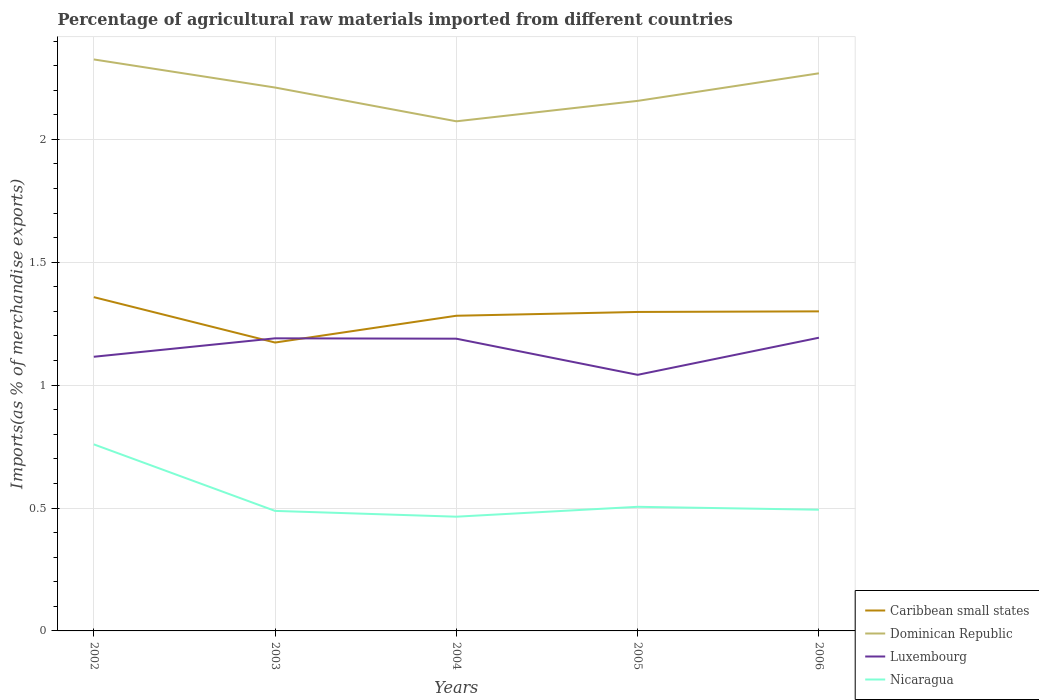Is the number of lines equal to the number of legend labels?
Ensure brevity in your answer.  Yes. Across all years, what is the maximum percentage of imports to different countries in Dominican Republic?
Keep it short and to the point. 2.07. In which year was the percentage of imports to different countries in Dominican Republic maximum?
Your answer should be compact. 2004. What is the total percentage of imports to different countries in Nicaragua in the graph?
Your answer should be compact. -0.03. What is the difference between the highest and the second highest percentage of imports to different countries in Dominican Republic?
Make the answer very short. 0.25. What is the difference between the highest and the lowest percentage of imports to different countries in Nicaragua?
Ensure brevity in your answer.  1. What is the difference between two consecutive major ticks on the Y-axis?
Offer a terse response. 0.5. Are the values on the major ticks of Y-axis written in scientific E-notation?
Provide a succinct answer. No. Does the graph contain grids?
Give a very brief answer. Yes. Where does the legend appear in the graph?
Your answer should be very brief. Bottom right. What is the title of the graph?
Offer a very short reply. Percentage of agricultural raw materials imported from different countries. Does "Faeroe Islands" appear as one of the legend labels in the graph?
Give a very brief answer. No. What is the label or title of the Y-axis?
Offer a very short reply. Imports(as % of merchandise exports). What is the Imports(as % of merchandise exports) of Caribbean small states in 2002?
Offer a very short reply. 1.36. What is the Imports(as % of merchandise exports) in Dominican Republic in 2002?
Make the answer very short. 2.33. What is the Imports(as % of merchandise exports) in Luxembourg in 2002?
Make the answer very short. 1.12. What is the Imports(as % of merchandise exports) of Nicaragua in 2002?
Make the answer very short. 0.76. What is the Imports(as % of merchandise exports) of Caribbean small states in 2003?
Make the answer very short. 1.17. What is the Imports(as % of merchandise exports) of Dominican Republic in 2003?
Keep it short and to the point. 2.21. What is the Imports(as % of merchandise exports) in Luxembourg in 2003?
Your answer should be compact. 1.19. What is the Imports(as % of merchandise exports) of Nicaragua in 2003?
Offer a very short reply. 0.49. What is the Imports(as % of merchandise exports) in Caribbean small states in 2004?
Your response must be concise. 1.28. What is the Imports(as % of merchandise exports) of Dominican Republic in 2004?
Keep it short and to the point. 2.07. What is the Imports(as % of merchandise exports) of Luxembourg in 2004?
Offer a very short reply. 1.19. What is the Imports(as % of merchandise exports) of Nicaragua in 2004?
Your answer should be compact. 0.46. What is the Imports(as % of merchandise exports) of Caribbean small states in 2005?
Provide a short and direct response. 1.3. What is the Imports(as % of merchandise exports) of Dominican Republic in 2005?
Provide a short and direct response. 2.16. What is the Imports(as % of merchandise exports) of Luxembourg in 2005?
Your answer should be compact. 1.04. What is the Imports(as % of merchandise exports) in Nicaragua in 2005?
Make the answer very short. 0.5. What is the Imports(as % of merchandise exports) in Caribbean small states in 2006?
Keep it short and to the point. 1.3. What is the Imports(as % of merchandise exports) in Dominican Republic in 2006?
Provide a succinct answer. 2.27. What is the Imports(as % of merchandise exports) in Luxembourg in 2006?
Your response must be concise. 1.19. What is the Imports(as % of merchandise exports) in Nicaragua in 2006?
Your answer should be very brief. 0.49. Across all years, what is the maximum Imports(as % of merchandise exports) in Caribbean small states?
Provide a succinct answer. 1.36. Across all years, what is the maximum Imports(as % of merchandise exports) of Dominican Republic?
Your answer should be very brief. 2.33. Across all years, what is the maximum Imports(as % of merchandise exports) of Luxembourg?
Keep it short and to the point. 1.19. Across all years, what is the maximum Imports(as % of merchandise exports) in Nicaragua?
Your answer should be compact. 0.76. Across all years, what is the minimum Imports(as % of merchandise exports) in Caribbean small states?
Make the answer very short. 1.17. Across all years, what is the minimum Imports(as % of merchandise exports) in Dominican Republic?
Make the answer very short. 2.07. Across all years, what is the minimum Imports(as % of merchandise exports) of Luxembourg?
Your response must be concise. 1.04. Across all years, what is the minimum Imports(as % of merchandise exports) in Nicaragua?
Provide a short and direct response. 0.46. What is the total Imports(as % of merchandise exports) in Caribbean small states in the graph?
Make the answer very short. 6.41. What is the total Imports(as % of merchandise exports) of Dominican Republic in the graph?
Provide a short and direct response. 11.03. What is the total Imports(as % of merchandise exports) in Luxembourg in the graph?
Ensure brevity in your answer.  5.73. What is the total Imports(as % of merchandise exports) in Nicaragua in the graph?
Give a very brief answer. 2.71. What is the difference between the Imports(as % of merchandise exports) in Caribbean small states in 2002 and that in 2003?
Ensure brevity in your answer.  0.18. What is the difference between the Imports(as % of merchandise exports) in Dominican Republic in 2002 and that in 2003?
Your answer should be very brief. 0.11. What is the difference between the Imports(as % of merchandise exports) in Luxembourg in 2002 and that in 2003?
Provide a short and direct response. -0.07. What is the difference between the Imports(as % of merchandise exports) of Nicaragua in 2002 and that in 2003?
Provide a short and direct response. 0.27. What is the difference between the Imports(as % of merchandise exports) in Caribbean small states in 2002 and that in 2004?
Your answer should be very brief. 0.08. What is the difference between the Imports(as % of merchandise exports) of Dominican Republic in 2002 and that in 2004?
Provide a short and direct response. 0.25. What is the difference between the Imports(as % of merchandise exports) in Luxembourg in 2002 and that in 2004?
Provide a succinct answer. -0.07. What is the difference between the Imports(as % of merchandise exports) in Nicaragua in 2002 and that in 2004?
Provide a short and direct response. 0.29. What is the difference between the Imports(as % of merchandise exports) of Caribbean small states in 2002 and that in 2005?
Offer a terse response. 0.06. What is the difference between the Imports(as % of merchandise exports) of Dominican Republic in 2002 and that in 2005?
Make the answer very short. 0.17. What is the difference between the Imports(as % of merchandise exports) of Luxembourg in 2002 and that in 2005?
Provide a succinct answer. 0.07. What is the difference between the Imports(as % of merchandise exports) of Nicaragua in 2002 and that in 2005?
Your answer should be compact. 0.25. What is the difference between the Imports(as % of merchandise exports) of Caribbean small states in 2002 and that in 2006?
Your answer should be compact. 0.06. What is the difference between the Imports(as % of merchandise exports) of Dominican Republic in 2002 and that in 2006?
Provide a succinct answer. 0.06. What is the difference between the Imports(as % of merchandise exports) of Luxembourg in 2002 and that in 2006?
Your answer should be compact. -0.08. What is the difference between the Imports(as % of merchandise exports) of Nicaragua in 2002 and that in 2006?
Provide a short and direct response. 0.27. What is the difference between the Imports(as % of merchandise exports) of Caribbean small states in 2003 and that in 2004?
Provide a short and direct response. -0.11. What is the difference between the Imports(as % of merchandise exports) in Dominican Republic in 2003 and that in 2004?
Provide a succinct answer. 0.14. What is the difference between the Imports(as % of merchandise exports) in Luxembourg in 2003 and that in 2004?
Provide a short and direct response. 0. What is the difference between the Imports(as % of merchandise exports) of Nicaragua in 2003 and that in 2004?
Offer a terse response. 0.02. What is the difference between the Imports(as % of merchandise exports) in Caribbean small states in 2003 and that in 2005?
Ensure brevity in your answer.  -0.12. What is the difference between the Imports(as % of merchandise exports) in Dominican Republic in 2003 and that in 2005?
Keep it short and to the point. 0.05. What is the difference between the Imports(as % of merchandise exports) in Luxembourg in 2003 and that in 2005?
Your answer should be compact. 0.15. What is the difference between the Imports(as % of merchandise exports) in Nicaragua in 2003 and that in 2005?
Offer a terse response. -0.02. What is the difference between the Imports(as % of merchandise exports) of Caribbean small states in 2003 and that in 2006?
Ensure brevity in your answer.  -0.13. What is the difference between the Imports(as % of merchandise exports) of Dominican Republic in 2003 and that in 2006?
Your response must be concise. -0.06. What is the difference between the Imports(as % of merchandise exports) of Luxembourg in 2003 and that in 2006?
Your response must be concise. -0. What is the difference between the Imports(as % of merchandise exports) of Nicaragua in 2003 and that in 2006?
Offer a terse response. -0. What is the difference between the Imports(as % of merchandise exports) of Caribbean small states in 2004 and that in 2005?
Your answer should be very brief. -0.02. What is the difference between the Imports(as % of merchandise exports) in Dominican Republic in 2004 and that in 2005?
Keep it short and to the point. -0.08. What is the difference between the Imports(as % of merchandise exports) of Luxembourg in 2004 and that in 2005?
Ensure brevity in your answer.  0.15. What is the difference between the Imports(as % of merchandise exports) of Nicaragua in 2004 and that in 2005?
Provide a succinct answer. -0.04. What is the difference between the Imports(as % of merchandise exports) of Caribbean small states in 2004 and that in 2006?
Provide a succinct answer. -0.02. What is the difference between the Imports(as % of merchandise exports) of Dominican Republic in 2004 and that in 2006?
Give a very brief answer. -0.2. What is the difference between the Imports(as % of merchandise exports) in Luxembourg in 2004 and that in 2006?
Your response must be concise. -0. What is the difference between the Imports(as % of merchandise exports) in Nicaragua in 2004 and that in 2006?
Make the answer very short. -0.03. What is the difference between the Imports(as % of merchandise exports) in Caribbean small states in 2005 and that in 2006?
Ensure brevity in your answer.  -0. What is the difference between the Imports(as % of merchandise exports) of Dominican Republic in 2005 and that in 2006?
Give a very brief answer. -0.11. What is the difference between the Imports(as % of merchandise exports) of Luxembourg in 2005 and that in 2006?
Make the answer very short. -0.15. What is the difference between the Imports(as % of merchandise exports) of Nicaragua in 2005 and that in 2006?
Give a very brief answer. 0.01. What is the difference between the Imports(as % of merchandise exports) in Caribbean small states in 2002 and the Imports(as % of merchandise exports) in Dominican Republic in 2003?
Offer a terse response. -0.85. What is the difference between the Imports(as % of merchandise exports) of Caribbean small states in 2002 and the Imports(as % of merchandise exports) of Luxembourg in 2003?
Your answer should be very brief. 0.17. What is the difference between the Imports(as % of merchandise exports) in Caribbean small states in 2002 and the Imports(as % of merchandise exports) in Nicaragua in 2003?
Your response must be concise. 0.87. What is the difference between the Imports(as % of merchandise exports) in Dominican Republic in 2002 and the Imports(as % of merchandise exports) in Luxembourg in 2003?
Provide a succinct answer. 1.13. What is the difference between the Imports(as % of merchandise exports) of Dominican Republic in 2002 and the Imports(as % of merchandise exports) of Nicaragua in 2003?
Your answer should be very brief. 1.84. What is the difference between the Imports(as % of merchandise exports) in Luxembourg in 2002 and the Imports(as % of merchandise exports) in Nicaragua in 2003?
Provide a short and direct response. 0.63. What is the difference between the Imports(as % of merchandise exports) in Caribbean small states in 2002 and the Imports(as % of merchandise exports) in Dominican Republic in 2004?
Your response must be concise. -0.72. What is the difference between the Imports(as % of merchandise exports) of Caribbean small states in 2002 and the Imports(as % of merchandise exports) of Luxembourg in 2004?
Offer a terse response. 0.17. What is the difference between the Imports(as % of merchandise exports) in Caribbean small states in 2002 and the Imports(as % of merchandise exports) in Nicaragua in 2004?
Offer a terse response. 0.89. What is the difference between the Imports(as % of merchandise exports) of Dominican Republic in 2002 and the Imports(as % of merchandise exports) of Luxembourg in 2004?
Your response must be concise. 1.14. What is the difference between the Imports(as % of merchandise exports) of Dominican Republic in 2002 and the Imports(as % of merchandise exports) of Nicaragua in 2004?
Your answer should be compact. 1.86. What is the difference between the Imports(as % of merchandise exports) in Luxembourg in 2002 and the Imports(as % of merchandise exports) in Nicaragua in 2004?
Offer a very short reply. 0.65. What is the difference between the Imports(as % of merchandise exports) of Caribbean small states in 2002 and the Imports(as % of merchandise exports) of Dominican Republic in 2005?
Make the answer very short. -0.8. What is the difference between the Imports(as % of merchandise exports) of Caribbean small states in 2002 and the Imports(as % of merchandise exports) of Luxembourg in 2005?
Give a very brief answer. 0.32. What is the difference between the Imports(as % of merchandise exports) of Caribbean small states in 2002 and the Imports(as % of merchandise exports) of Nicaragua in 2005?
Ensure brevity in your answer.  0.85. What is the difference between the Imports(as % of merchandise exports) of Dominican Republic in 2002 and the Imports(as % of merchandise exports) of Luxembourg in 2005?
Offer a terse response. 1.28. What is the difference between the Imports(as % of merchandise exports) in Dominican Republic in 2002 and the Imports(as % of merchandise exports) in Nicaragua in 2005?
Provide a succinct answer. 1.82. What is the difference between the Imports(as % of merchandise exports) in Luxembourg in 2002 and the Imports(as % of merchandise exports) in Nicaragua in 2005?
Keep it short and to the point. 0.61. What is the difference between the Imports(as % of merchandise exports) in Caribbean small states in 2002 and the Imports(as % of merchandise exports) in Dominican Republic in 2006?
Keep it short and to the point. -0.91. What is the difference between the Imports(as % of merchandise exports) of Caribbean small states in 2002 and the Imports(as % of merchandise exports) of Luxembourg in 2006?
Offer a terse response. 0.17. What is the difference between the Imports(as % of merchandise exports) of Caribbean small states in 2002 and the Imports(as % of merchandise exports) of Nicaragua in 2006?
Offer a terse response. 0.86. What is the difference between the Imports(as % of merchandise exports) in Dominican Republic in 2002 and the Imports(as % of merchandise exports) in Luxembourg in 2006?
Provide a short and direct response. 1.13. What is the difference between the Imports(as % of merchandise exports) in Dominican Republic in 2002 and the Imports(as % of merchandise exports) in Nicaragua in 2006?
Provide a short and direct response. 1.83. What is the difference between the Imports(as % of merchandise exports) of Luxembourg in 2002 and the Imports(as % of merchandise exports) of Nicaragua in 2006?
Keep it short and to the point. 0.62. What is the difference between the Imports(as % of merchandise exports) of Caribbean small states in 2003 and the Imports(as % of merchandise exports) of Dominican Republic in 2004?
Provide a succinct answer. -0.9. What is the difference between the Imports(as % of merchandise exports) in Caribbean small states in 2003 and the Imports(as % of merchandise exports) in Luxembourg in 2004?
Your answer should be very brief. -0.02. What is the difference between the Imports(as % of merchandise exports) of Caribbean small states in 2003 and the Imports(as % of merchandise exports) of Nicaragua in 2004?
Your answer should be compact. 0.71. What is the difference between the Imports(as % of merchandise exports) of Dominican Republic in 2003 and the Imports(as % of merchandise exports) of Luxembourg in 2004?
Provide a succinct answer. 1.02. What is the difference between the Imports(as % of merchandise exports) of Dominican Republic in 2003 and the Imports(as % of merchandise exports) of Nicaragua in 2004?
Ensure brevity in your answer.  1.75. What is the difference between the Imports(as % of merchandise exports) of Luxembourg in 2003 and the Imports(as % of merchandise exports) of Nicaragua in 2004?
Offer a terse response. 0.73. What is the difference between the Imports(as % of merchandise exports) in Caribbean small states in 2003 and the Imports(as % of merchandise exports) in Dominican Republic in 2005?
Keep it short and to the point. -0.98. What is the difference between the Imports(as % of merchandise exports) of Caribbean small states in 2003 and the Imports(as % of merchandise exports) of Luxembourg in 2005?
Your response must be concise. 0.13. What is the difference between the Imports(as % of merchandise exports) of Caribbean small states in 2003 and the Imports(as % of merchandise exports) of Nicaragua in 2005?
Provide a short and direct response. 0.67. What is the difference between the Imports(as % of merchandise exports) in Dominican Republic in 2003 and the Imports(as % of merchandise exports) in Luxembourg in 2005?
Your answer should be very brief. 1.17. What is the difference between the Imports(as % of merchandise exports) in Dominican Republic in 2003 and the Imports(as % of merchandise exports) in Nicaragua in 2005?
Ensure brevity in your answer.  1.71. What is the difference between the Imports(as % of merchandise exports) in Luxembourg in 2003 and the Imports(as % of merchandise exports) in Nicaragua in 2005?
Make the answer very short. 0.69. What is the difference between the Imports(as % of merchandise exports) in Caribbean small states in 2003 and the Imports(as % of merchandise exports) in Dominican Republic in 2006?
Provide a short and direct response. -1.1. What is the difference between the Imports(as % of merchandise exports) in Caribbean small states in 2003 and the Imports(as % of merchandise exports) in Luxembourg in 2006?
Provide a succinct answer. -0.02. What is the difference between the Imports(as % of merchandise exports) of Caribbean small states in 2003 and the Imports(as % of merchandise exports) of Nicaragua in 2006?
Provide a succinct answer. 0.68. What is the difference between the Imports(as % of merchandise exports) in Dominican Republic in 2003 and the Imports(as % of merchandise exports) in Luxembourg in 2006?
Make the answer very short. 1.02. What is the difference between the Imports(as % of merchandise exports) in Dominican Republic in 2003 and the Imports(as % of merchandise exports) in Nicaragua in 2006?
Give a very brief answer. 1.72. What is the difference between the Imports(as % of merchandise exports) of Luxembourg in 2003 and the Imports(as % of merchandise exports) of Nicaragua in 2006?
Offer a very short reply. 0.7. What is the difference between the Imports(as % of merchandise exports) in Caribbean small states in 2004 and the Imports(as % of merchandise exports) in Dominican Republic in 2005?
Make the answer very short. -0.87. What is the difference between the Imports(as % of merchandise exports) of Caribbean small states in 2004 and the Imports(as % of merchandise exports) of Luxembourg in 2005?
Your answer should be compact. 0.24. What is the difference between the Imports(as % of merchandise exports) of Caribbean small states in 2004 and the Imports(as % of merchandise exports) of Nicaragua in 2005?
Offer a very short reply. 0.78. What is the difference between the Imports(as % of merchandise exports) of Dominican Republic in 2004 and the Imports(as % of merchandise exports) of Luxembourg in 2005?
Ensure brevity in your answer.  1.03. What is the difference between the Imports(as % of merchandise exports) of Dominican Republic in 2004 and the Imports(as % of merchandise exports) of Nicaragua in 2005?
Offer a terse response. 1.57. What is the difference between the Imports(as % of merchandise exports) of Luxembourg in 2004 and the Imports(as % of merchandise exports) of Nicaragua in 2005?
Make the answer very short. 0.68. What is the difference between the Imports(as % of merchandise exports) of Caribbean small states in 2004 and the Imports(as % of merchandise exports) of Dominican Republic in 2006?
Make the answer very short. -0.99. What is the difference between the Imports(as % of merchandise exports) in Caribbean small states in 2004 and the Imports(as % of merchandise exports) in Luxembourg in 2006?
Offer a very short reply. 0.09. What is the difference between the Imports(as % of merchandise exports) in Caribbean small states in 2004 and the Imports(as % of merchandise exports) in Nicaragua in 2006?
Your response must be concise. 0.79. What is the difference between the Imports(as % of merchandise exports) of Dominican Republic in 2004 and the Imports(as % of merchandise exports) of Luxembourg in 2006?
Your answer should be very brief. 0.88. What is the difference between the Imports(as % of merchandise exports) in Dominican Republic in 2004 and the Imports(as % of merchandise exports) in Nicaragua in 2006?
Your answer should be compact. 1.58. What is the difference between the Imports(as % of merchandise exports) in Luxembourg in 2004 and the Imports(as % of merchandise exports) in Nicaragua in 2006?
Offer a very short reply. 0.7. What is the difference between the Imports(as % of merchandise exports) in Caribbean small states in 2005 and the Imports(as % of merchandise exports) in Dominican Republic in 2006?
Keep it short and to the point. -0.97. What is the difference between the Imports(as % of merchandise exports) of Caribbean small states in 2005 and the Imports(as % of merchandise exports) of Luxembourg in 2006?
Ensure brevity in your answer.  0.1. What is the difference between the Imports(as % of merchandise exports) in Caribbean small states in 2005 and the Imports(as % of merchandise exports) in Nicaragua in 2006?
Offer a terse response. 0.8. What is the difference between the Imports(as % of merchandise exports) in Dominican Republic in 2005 and the Imports(as % of merchandise exports) in Luxembourg in 2006?
Offer a very short reply. 0.96. What is the difference between the Imports(as % of merchandise exports) in Dominican Republic in 2005 and the Imports(as % of merchandise exports) in Nicaragua in 2006?
Give a very brief answer. 1.66. What is the difference between the Imports(as % of merchandise exports) in Luxembourg in 2005 and the Imports(as % of merchandise exports) in Nicaragua in 2006?
Make the answer very short. 0.55. What is the average Imports(as % of merchandise exports) in Caribbean small states per year?
Make the answer very short. 1.28. What is the average Imports(as % of merchandise exports) of Dominican Republic per year?
Provide a succinct answer. 2.21. What is the average Imports(as % of merchandise exports) of Luxembourg per year?
Offer a terse response. 1.15. What is the average Imports(as % of merchandise exports) in Nicaragua per year?
Keep it short and to the point. 0.54. In the year 2002, what is the difference between the Imports(as % of merchandise exports) of Caribbean small states and Imports(as % of merchandise exports) of Dominican Republic?
Offer a very short reply. -0.97. In the year 2002, what is the difference between the Imports(as % of merchandise exports) in Caribbean small states and Imports(as % of merchandise exports) in Luxembourg?
Offer a very short reply. 0.24. In the year 2002, what is the difference between the Imports(as % of merchandise exports) of Caribbean small states and Imports(as % of merchandise exports) of Nicaragua?
Your response must be concise. 0.6. In the year 2002, what is the difference between the Imports(as % of merchandise exports) of Dominican Republic and Imports(as % of merchandise exports) of Luxembourg?
Give a very brief answer. 1.21. In the year 2002, what is the difference between the Imports(as % of merchandise exports) in Dominican Republic and Imports(as % of merchandise exports) in Nicaragua?
Your answer should be compact. 1.57. In the year 2002, what is the difference between the Imports(as % of merchandise exports) of Luxembourg and Imports(as % of merchandise exports) of Nicaragua?
Your response must be concise. 0.36. In the year 2003, what is the difference between the Imports(as % of merchandise exports) of Caribbean small states and Imports(as % of merchandise exports) of Dominican Republic?
Your answer should be compact. -1.04. In the year 2003, what is the difference between the Imports(as % of merchandise exports) of Caribbean small states and Imports(as % of merchandise exports) of Luxembourg?
Offer a very short reply. -0.02. In the year 2003, what is the difference between the Imports(as % of merchandise exports) in Caribbean small states and Imports(as % of merchandise exports) in Nicaragua?
Provide a short and direct response. 0.69. In the year 2003, what is the difference between the Imports(as % of merchandise exports) of Dominican Republic and Imports(as % of merchandise exports) of Luxembourg?
Your answer should be compact. 1.02. In the year 2003, what is the difference between the Imports(as % of merchandise exports) of Dominican Republic and Imports(as % of merchandise exports) of Nicaragua?
Provide a succinct answer. 1.72. In the year 2003, what is the difference between the Imports(as % of merchandise exports) in Luxembourg and Imports(as % of merchandise exports) in Nicaragua?
Your answer should be very brief. 0.7. In the year 2004, what is the difference between the Imports(as % of merchandise exports) in Caribbean small states and Imports(as % of merchandise exports) in Dominican Republic?
Ensure brevity in your answer.  -0.79. In the year 2004, what is the difference between the Imports(as % of merchandise exports) in Caribbean small states and Imports(as % of merchandise exports) in Luxembourg?
Provide a succinct answer. 0.09. In the year 2004, what is the difference between the Imports(as % of merchandise exports) in Caribbean small states and Imports(as % of merchandise exports) in Nicaragua?
Your answer should be compact. 0.82. In the year 2004, what is the difference between the Imports(as % of merchandise exports) in Dominican Republic and Imports(as % of merchandise exports) in Luxembourg?
Your answer should be compact. 0.88. In the year 2004, what is the difference between the Imports(as % of merchandise exports) of Dominican Republic and Imports(as % of merchandise exports) of Nicaragua?
Provide a short and direct response. 1.61. In the year 2004, what is the difference between the Imports(as % of merchandise exports) in Luxembourg and Imports(as % of merchandise exports) in Nicaragua?
Ensure brevity in your answer.  0.72. In the year 2005, what is the difference between the Imports(as % of merchandise exports) in Caribbean small states and Imports(as % of merchandise exports) in Dominican Republic?
Offer a very short reply. -0.86. In the year 2005, what is the difference between the Imports(as % of merchandise exports) in Caribbean small states and Imports(as % of merchandise exports) in Luxembourg?
Ensure brevity in your answer.  0.26. In the year 2005, what is the difference between the Imports(as % of merchandise exports) in Caribbean small states and Imports(as % of merchandise exports) in Nicaragua?
Keep it short and to the point. 0.79. In the year 2005, what is the difference between the Imports(as % of merchandise exports) of Dominican Republic and Imports(as % of merchandise exports) of Luxembourg?
Ensure brevity in your answer.  1.11. In the year 2005, what is the difference between the Imports(as % of merchandise exports) of Dominican Republic and Imports(as % of merchandise exports) of Nicaragua?
Provide a succinct answer. 1.65. In the year 2005, what is the difference between the Imports(as % of merchandise exports) in Luxembourg and Imports(as % of merchandise exports) in Nicaragua?
Your answer should be very brief. 0.54. In the year 2006, what is the difference between the Imports(as % of merchandise exports) in Caribbean small states and Imports(as % of merchandise exports) in Dominican Republic?
Your response must be concise. -0.97. In the year 2006, what is the difference between the Imports(as % of merchandise exports) in Caribbean small states and Imports(as % of merchandise exports) in Luxembourg?
Your response must be concise. 0.11. In the year 2006, what is the difference between the Imports(as % of merchandise exports) of Caribbean small states and Imports(as % of merchandise exports) of Nicaragua?
Offer a terse response. 0.81. In the year 2006, what is the difference between the Imports(as % of merchandise exports) in Dominican Republic and Imports(as % of merchandise exports) in Luxembourg?
Offer a very short reply. 1.08. In the year 2006, what is the difference between the Imports(as % of merchandise exports) in Dominican Republic and Imports(as % of merchandise exports) in Nicaragua?
Your answer should be compact. 1.78. In the year 2006, what is the difference between the Imports(as % of merchandise exports) in Luxembourg and Imports(as % of merchandise exports) in Nicaragua?
Provide a succinct answer. 0.7. What is the ratio of the Imports(as % of merchandise exports) of Caribbean small states in 2002 to that in 2003?
Make the answer very short. 1.16. What is the ratio of the Imports(as % of merchandise exports) in Dominican Republic in 2002 to that in 2003?
Offer a very short reply. 1.05. What is the ratio of the Imports(as % of merchandise exports) in Luxembourg in 2002 to that in 2003?
Ensure brevity in your answer.  0.94. What is the ratio of the Imports(as % of merchandise exports) in Nicaragua in 2002 to that in 2003?
Offer a terse response. 1.55. What is the ratio of the Imports(as % of merchandise exports) in Caribbean small states in 2002 to that in 2004?
Ensure brevity in your answer.  1.06. What is the ratio of the Imports(as % of merchandise exports) of Dominican Republic in 2002 to that in 2004?
Offer a very short reply. 1.12. What is the ratio of the Imports(as % of merchandise exports) in Luxembourg in 2002 to that in 2004?
Keep it short and to the point. 0.94. What is the ratio of the Imports(as % of merchandise exports) in Nicaragua in 2002 to that in 2004?
Give a very brief answer. 1.63. What is the ratio of the Imports(as % of merchandise exports) in Caribbean small states in 2002 to that in 2005?
Your answer should be compact. 1.05. What is the ratio of the Imports(as % of merchandise exports) of Dominican Republic in 2002 to that in 2005?
Keep it short and to the point. 1.08. What is the ratio of the Imports(as % of merchandise exports) of Luxembourg in 2002 to that in 2005?
Your response must be concise. 1.07. What is the ratio of the Imports(as % of merchandise exports) in Nicaragua in 2002 to that in 2005?
Offer a terse response. 1.5. What is the ratio of the Imports(as % of merchandise exports) in Caribbean small states in 2002 to that in 2006?
Your response must be concise. 1.04. What is the ratio of the Imports(as % of merchandise exports) of Dominican Republic in 2002 to that in 2006?
Give a very brief answer. 1.02. What is the ratio of the Imports(as % of merchandise exports) of Luxembourg in 2002 to that in 2006?
Provide a succinct answer. 0.94. What is the ratio of the Imports(as % of merchandise exports) in Nicaragua in 2002 to that in 2006?
Your response must be concise. 1.54. What is the ratio of the Imports(as % of merchandise exports) of Caribbean small states in 2003 to that in 2004?
Your answer should be compact. 0.92. What is the ratio of the Imports(as % of merchandise exports) of Dominican Republic in 2003 to that in 2004?
Your answer should be very brief. 1.07. What is the ratio of the Imports(as % of merchandise exports) in Nicaragua in 2003 to that in 2004?
Offer a terse response. 1.05. What is the ratio of the Imports(as % of merchandise exports) of Caribbean small states in 2003 to that in 2005?
Provide a short and direct response. 0.9. What is the ratio of the Imports(as % of merchandise exports) of Dominican Republic in 2003 to that in 2005?
Your answer should be compact. 1.03. What is the ratio of the Imports(as % of merchandise exports) of Luxembourg in 2003 to that in 2005?
Your response must be concise. 1.14. What is the ratio of the Imports(as % of merchandise exports) in Caribbean small states in 2003 to that in 2006?
Ensure brevity in your answer.  0.9. What is the ratio of the Imports(as % of merchandise exports) of Dominican Republic in 2003 to that in 2006?
Ensure brevity in your answer.  0.97. What is the ratio of the Imports(as % of merchandise exports) of Nicaragua in 2003 to that in 2006?
Your answer should be very brief. 0.99. What is the ratio of the Imports(as % of merchandise exports) in Dominican Republic in 2004 to that in 2005?
Your response must be concise. 0.96. What is the ratio of the Imports(as % of merchandise exports) in Luxembourg in 2004 to that in 2005?
Your answer should be compact. 1.14. What is the ratio of the Imports(as % of merchandise exports) of Nicaragua in 2004 to that in 2005?
Your answer should be very brief. 0.92. What is the ratio of the Imports(as % of merchandise exports) in Caribbean small states in 2004 to that in 2006?
Ensure brevity in your answer.  0.99. What is the ratio of the Imports(as % of merchandise exports) in Dominican Republic in 2004 to that in 2006?
Your response must be concise. 0.91. What is the ratio of the Imports(as % of merchandise exports) in Nicaragua in 2004 to that in 2006?
Keep it short and to the point. 0.94. What is the ratio of the Imports(as % of merchandise exports) in Dominican Republic in 2005 to that in 2006?
Offer a terse response. 0.95. What is the ratio of the Imports(as % of merchandise exports) in Luxembourg in 2005 to that in 2006?
Provide a succinct answer. 0.87. What is the ratio of the Imports(as % of merchandise exports) in Nicaragua in 2005 to that in 2006?
Provide a short and direct response. 1.02. What is the difference between the highest and the second highest Imports(as % of merchandise exports) in Caribbean small states?
Provide a succinct answer. 0.06. What is the difference between the highest and the second highest Imports(as % of merchandise exports) of Dominican Republic?
Your answer should be compact. 0.06. What is the difference between the highest and the second highest Imports(as % of merchandise exports) in Luxembourg?
Your response must be concise. 0. What is the difference between the highest and the second highest Imports(as % of merchandise exports) of Nicaragua?
Your answer should be very brief. 0.25. What is the difference between the highest and the lowest Imports(as % of merchandise exports) of Caribbean small states?
Offer a terse response. 0.18. What is the difference between the highest and the lowest Imports(as % of merchandise exports) of Dominican Republic?
Your answer should be compact. 0.25. What is the difference between the highest and the lowest Imports(as % of merchandise exports) in Luxembourg?
Provide a succinct answer. 0.15. What is the difference between the highest and the lowest Imports(as % of merchandise exports) of Nicaragua?
Offer a terse response. 0.29. 